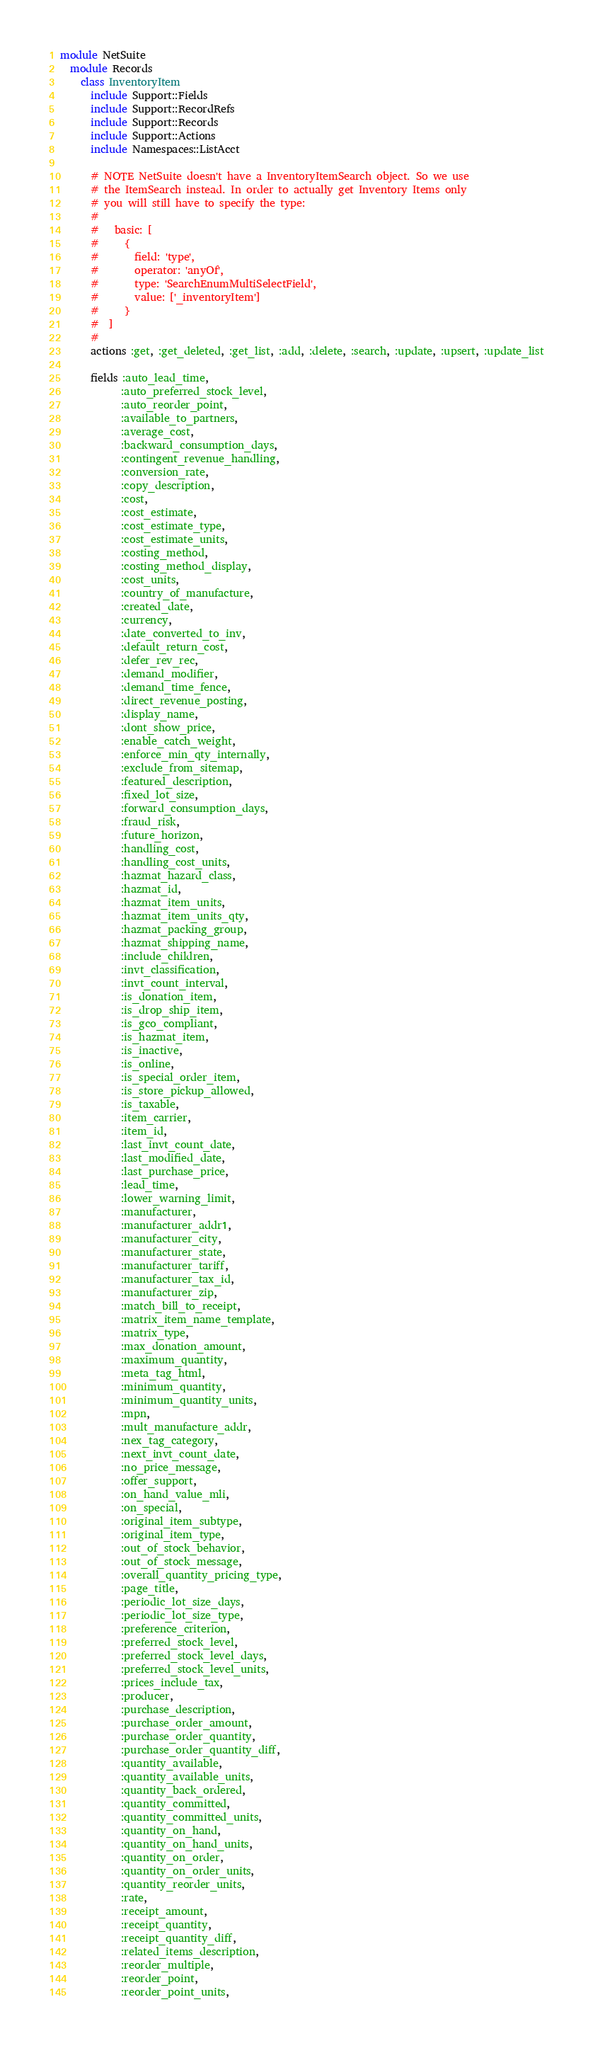Convert code to text. <code><loc_0><loc_0><loc_500><loc_500><_Ruby_>module NetSuite
  module Records
    class InventoryItem
      include Support::Fields
      include Support::RecordRefs
      include Support::Records
      include Support::Actions
      include Namespaces::ListAcct

      # NOTE NetSuite doesn't have a InventoryItemSearch object. So we use
      # the ItemSearch instead. In order to actually get Inventory Items only
      # you will still have to specify the type:
      #
      #   basic: [
      #     {
      #       field: 'type',
      #       operator: 'anyOf',
      #       type: 'SearchEnumMultiSelectField',
      #       value: ['_inventoryItem']
      #     }
      #  ]
      #
      actions :get, :get_deleted, :get_list, :add, :delete, :search, :update, :upsert, :update_list

      fields :auto_lead_time,
            :auto_preferred_stock_level,
            :auto_reorder_point,
            :available_to_partners,
            :average_cost,
            :backward_consumption_days,
            :contingent_revenue_handling,
            :conversion_rate,
            :copy_description,
            :cost,
            :cost_estimate,
            :cost_estimate_type,
            :cost_estimate_units,
            :costing_method,
            :costing_method_display,
            :cost_units,
            :country_of_manufacture,
            :created_date,
            :currency,
            :date_converted_to_inv,
            :default_return_cost,
            :defer_rev_rec,
            :demand_modifier,
            :demand_time_fence,
            :direct_revenue_posting,
            :display_name,
            :dont_show_price,
            :enable_catch_weight,
            :enforce_min_qty_internally,
            :exclude_from_sitemap,
            :featured_description,
            :fixed_lot_size,
            :forward_consumption_days,
            :fraud_risk,
            :future_horizon,
            :handling_cost,
            :handling_cost_units,
            :hazmat_hazard_class,
            :hazmat_id,
            :hazmat_item_units,
            :hazmat_item_units_qty,
            :hazmat_packing_group,
            :hazmat_shipping_name,
            :include_children,
            :invt_classification,
            :invt_count_interval,
            :is_donation_item,
            :is_drop_ship_item,
            :is_gco_compliant,
            :is_hazmat_item,
            :is_inactive,
            :is_online,
            :is_special_order_item,
            :is_store_pickup_allowed,
            :is_taxable,
            :item_carrier,
            :item_id,
            :last_invt_count_date,
            :last_modified_date,
            :last_purchase_price,
            :lead_time,
            :lower_warning_limit,
            :manufacturer,
            :manufacturer_addr1,
            :manufacturer_city,
            :manufacturer_state,
            :manufacturer_tariff,
            :manufacturer_tax_id,
            :manufacturer_zip,
            :match_bill_to_receipt,
            :matrix_item_name_template,
            :matrix_type,
            :max_donation_amount,
            :maximum_quantity,
            :meta_tag_html,
            :minimum_quantity,
            :minimum_quantity_units,
            :mpn,
            :mult_manufacture_addr,
            :nex_tag_category,
            :next_invt_count_date,
            :no_price_message,
            :offer_support,
            :on_hand_value_mli,
            :on_special,
            :original_item_subtype,
            :original_item_type,
            :out_of_stock_behavior,
            :out_of_stock_message,
            :overall_quantity_pricing_type,
            :page_title,
            :periodic_lot_size_days,
            :periodic_lot_size_type,
            :preference_criterion,
            :preferred_stock_level,
            :preferred_stock_level_days,
            :preferred_stock_level_units,
            :prices_include_tax,
            :producer,
            :purchase_description,
            :purchase_order_amount,
            :purchase_order_quantity,
            :purchase_order_quantity_diff,
            :quantity_available,
            :quantity_available_units,
            :quantity_back_ordered,
            :quantity_committed,
            :quantity_committed_units,
            :quantity_on_hand,
            :quantity_on_hand_units,
            :quantity_on_order,
            :quantity_on_order_units,
            :quantity_reorder_units,
            :rate,
            :receipt_amount,
            :receipt_quantity,
            :receipt_quantity_diff,
            :related_items_description,
            :reorder_multiple,
            :reorder_point,
            :reorder_point_units,</code> 